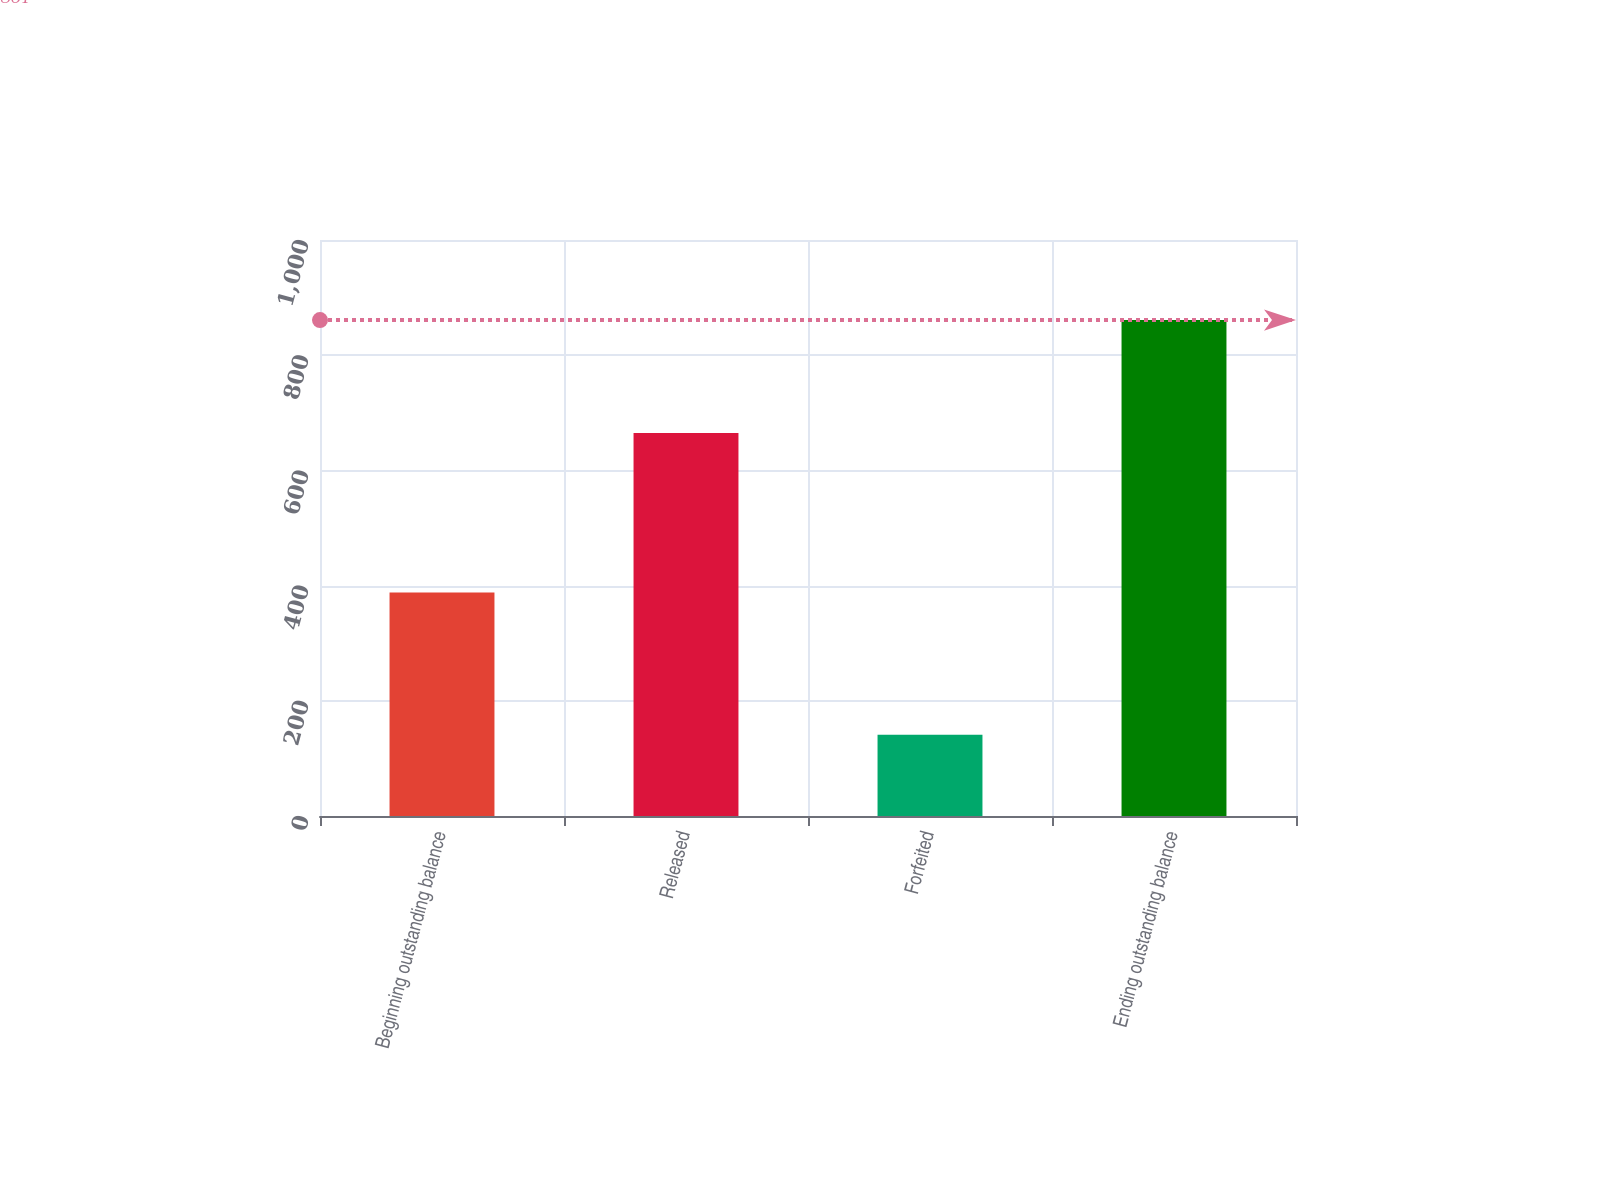Convert chart to OTSL. <chart><loc_0><loc_0><loc_500><loc_500><bar_chart><fcel>Beginning outstanding balance<fcel>Released<fcel>Forfeited<fcel>Ending outstanding balance<nl><fcel>388<fcel>665<fcel>141<fcel>861<nl></chart> 